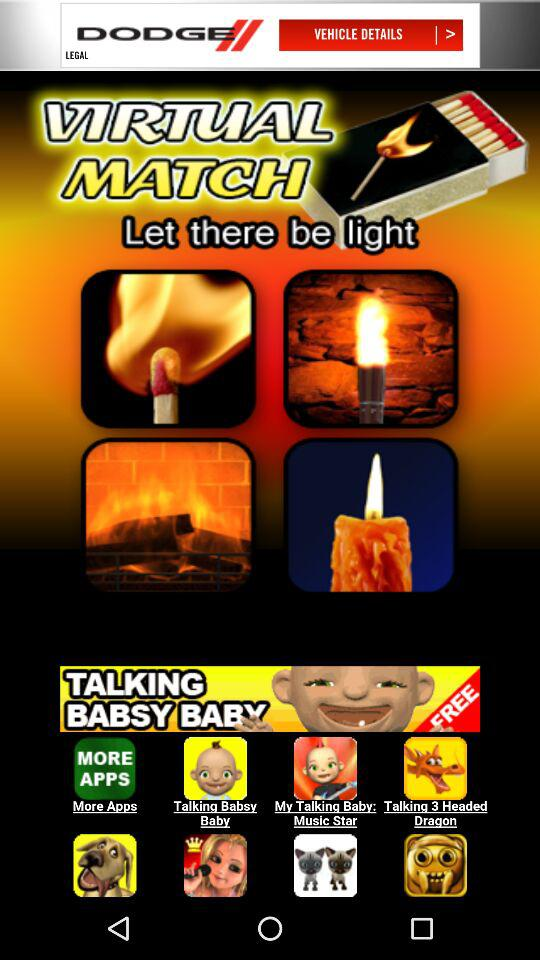Who developed the "Virtual Lighter" app?
When the provided information is insufficient, respond with <no answer>. <no answer> 